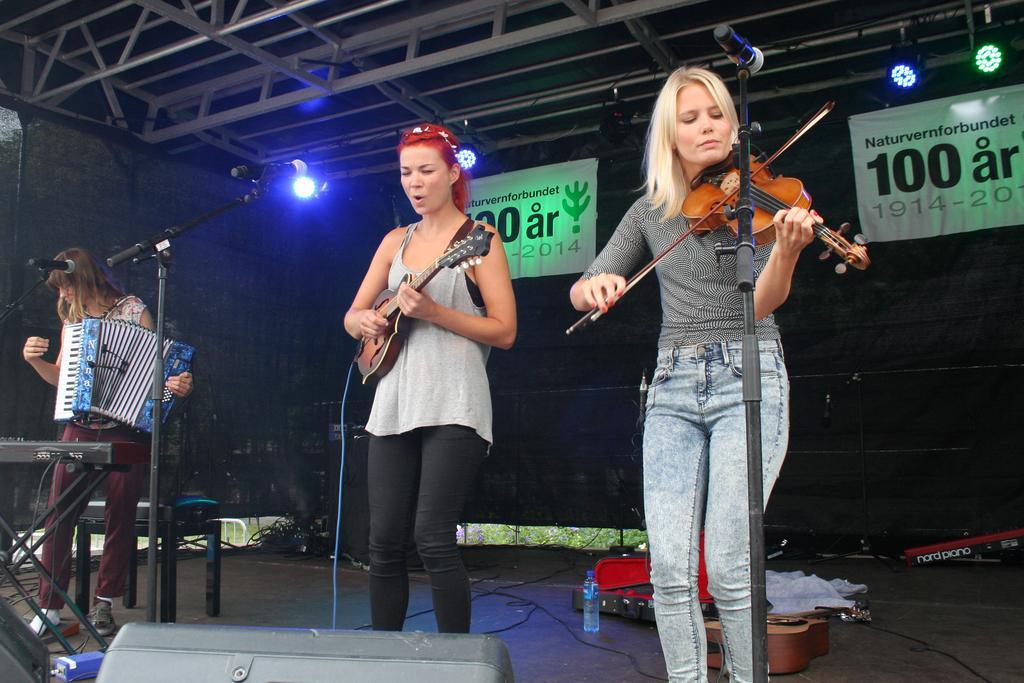Please provide a concise description of this image. There is a woman standing on the right side and she is playing a guitar. There is a woman standing in the center. She is holding a guitar and she is singing on a microphone. There is another woman on the left side and she is playing a piano. This is a roof with lighting arrangement. 